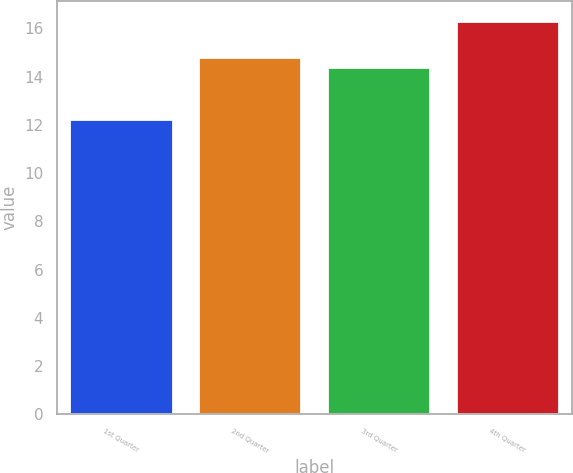Convert chart. <chart><loc_0><loc_0><loc_500><loc_500><bar_chart><fcel>1st Quarter<fcel>2nd Quarter<fcel>3rd Quarter<fcel>4th Quarter<nl><fcel>12.24<fcel>14.81<fcel>14.4<fcel>16.32<nl></chart> 